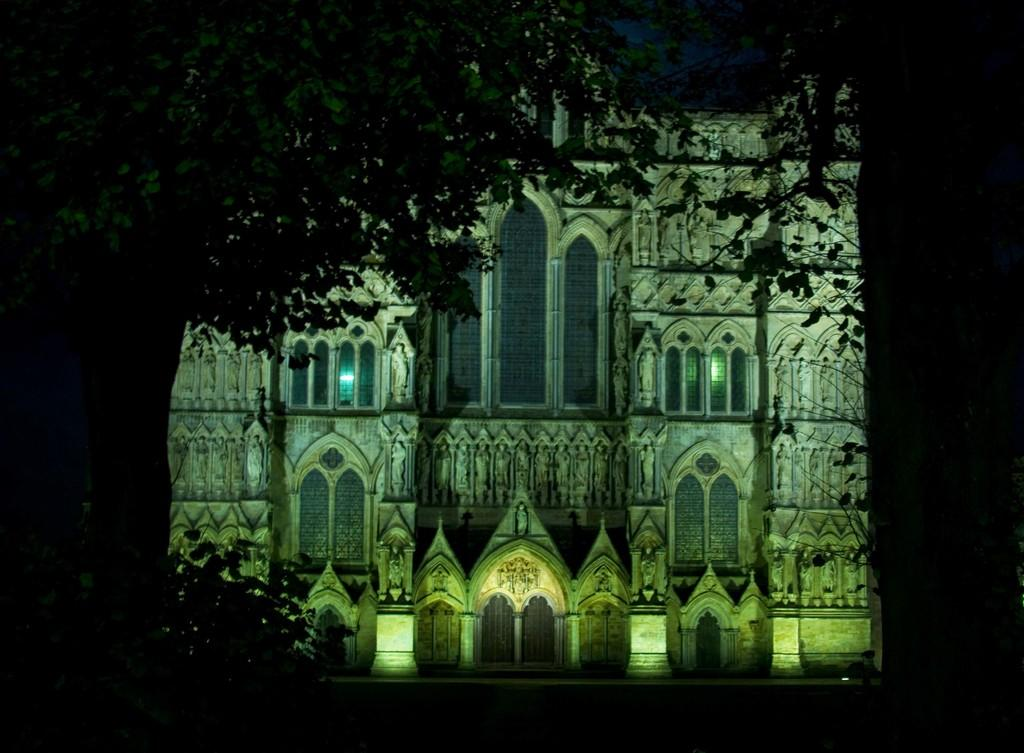What type of structure can be seen in the image? There is a building in the image. What other elements are present in the image besides the building? There are trees in the image. What type of rhythm can be heard coming from the building in the image? There is no indication of sound or rhythm in the image, as it only features a building and trees. 